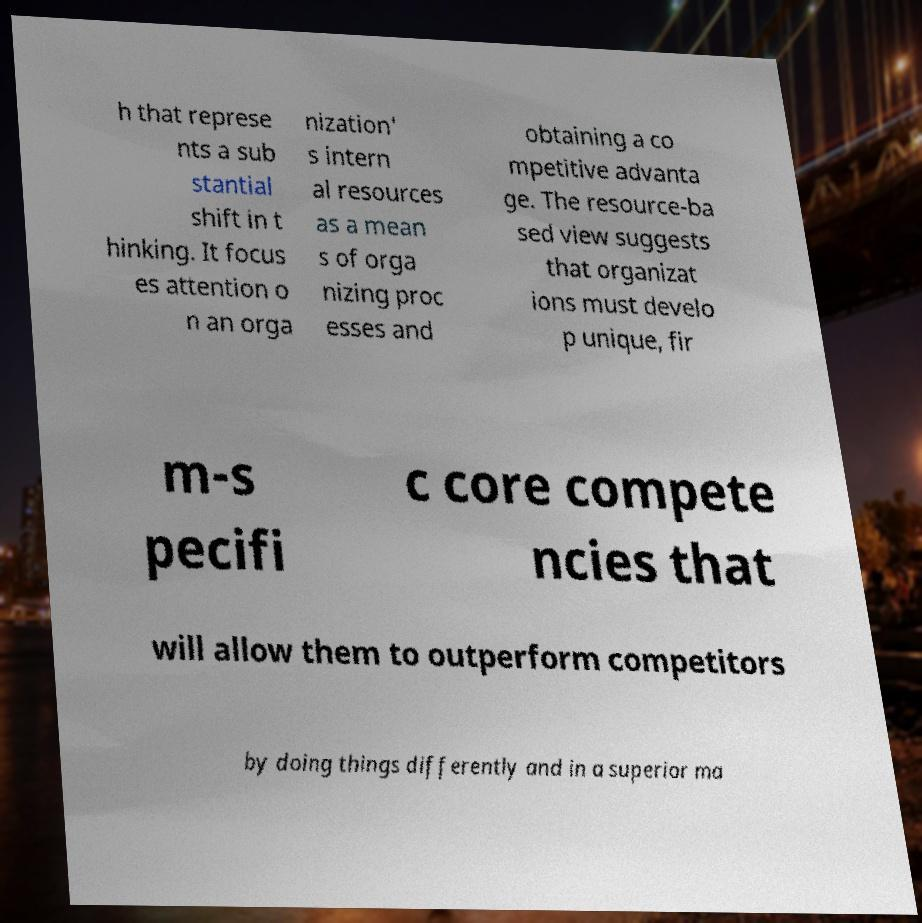Can you read and provide the text displayed in the image?This photo seems to have some interesting text. Can you extract and type it out for me? h that represe nts a sub stantial shift in t hinking. It focus es attention o n an orga nization' s intern al resources as a mean s of orga nizing proc esses and obtaining a co mpetitive advanta ge. The resource-ba sed view suggests that organizat ions must develo p unique, fir m-s pecifi c core compete ncies that will allow them to outperform competitors by doing things differently and in a superior ma 